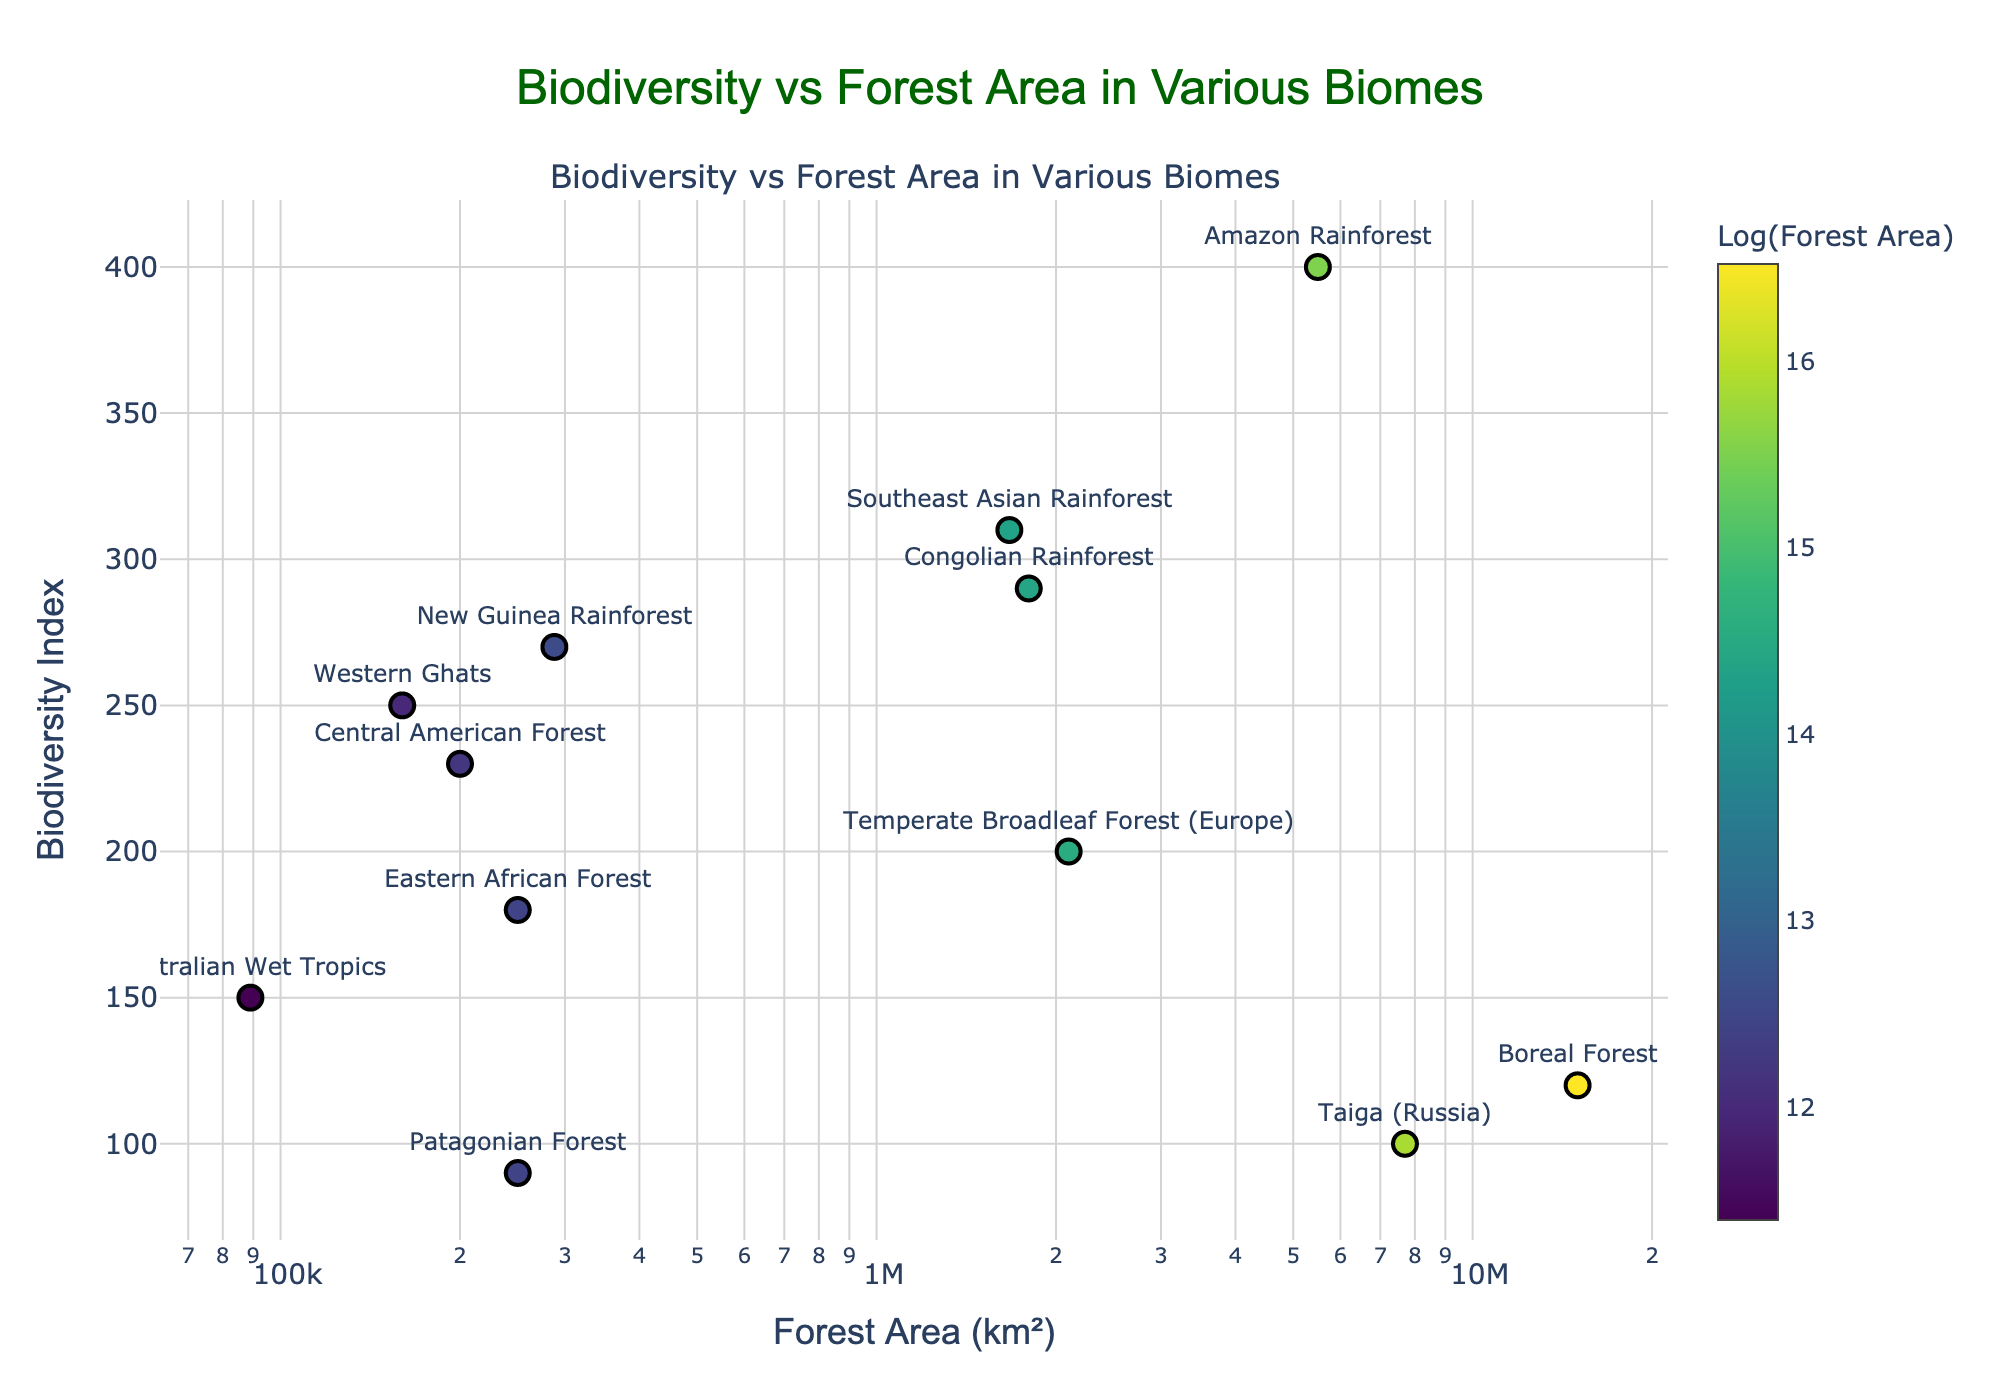How many biomes are displayed in the scatter plot? Count the number of biomes listed in the dataset provided in the figure. There are 12 distinct biomes.
Answer: 12 Which biome has the highest Biodiversity Index, and what is its corresponding Forest Area? Identify the data point with the highest y-value in the scatter plot. The Amazon Rainforest has the highest Biodiversity Index of 400. Its corresponding Forest Area is 5,500,000 km².
Answer: Amazon Rainforest; 5,500,000 km² According to the scatter plot, which biome has the smallest forest area, and what is its Biodiversity Index? Find the data point with the smallest x-value (smallest forest area) in the scatter plot. The Australian Wet Tropics has the smallest forest area of 89,000 km². Its Biodiversity Index is 150.
Answer: Australian Wet Tropics; 150 What is the range of the Biodiversity Index in the scatter plot? To find the range, subtract the smallest Biodiversity Index value from the largest Biodiversity Index value. The maximum Biodiversity Index is 400, and the minimum is 90, so the range is 400 - 90.
Answer: 310 Which biomes have a Forest Area greater than 1,000,000 km² and a Biodiversity Index less than 200? Locate biomes above the x-axis value corresponding to 1,000,000 km² and below the y-axis value of 200. Boreal Forest and Taiga have a Forest Area greater than 1,000,000 km² and a Biodiversity Index less than 200.
Answer: Boreal Forest, Taiga What does the color of the markers represent in the scatter plot? Refer to the color bar legend for an explanation of the color coding in the plot. The color of the markers represents the log-transformed values of the Forest Area for each biome.
Answer: Log(Forest Area) Is there a general trend between Forest Area and Biodiversity Index in the biomes shown? Examine the scatter plot to determine if a pattern or trend exists between the x-axis and y-axis variables. Generally, there seems to be a negative correlation, with larger forest areas often having lower Biodiversity Index values.
Answer: Negative correlation Which biome has a similar Biodiversity Index but a significantly smaller Forest Area compared to the Amazon Rainforest? Identify biomes with a Biodiversity Index close to 400 but with a smaller Forest Area compared to the Amazon Rainforest's 5,500,000 km². Southeast Asian Rainforest, Congolian Rainforest, and New Guinea Rainforest have Biodiversity Indices close to the Amazon Rainforest but significantly smaller Forest Areas.
Answer: Southeast Asian Rainforest; Congolian Rainforest; New Guinea Rainforest What is the average Biodiversity Index of biomes with a Forest Area less than 250,000 km²? Identify biomes with Forest Areas less than 250,000 km² and calculate the average Biodiversity Index of these biomes. (Western Ghats: 250, Eastern African Forest: 180, Central American Forest: 230, Australian Wet Tropics: 150, Patagonian Forest: 90). Add their Biodiversity Indices (250 + 180 + 230 + 150 + 90 = 900) and divide by the number of biomes (5). The average Biodiversity Index = 900 / 5.
Answer: 180 